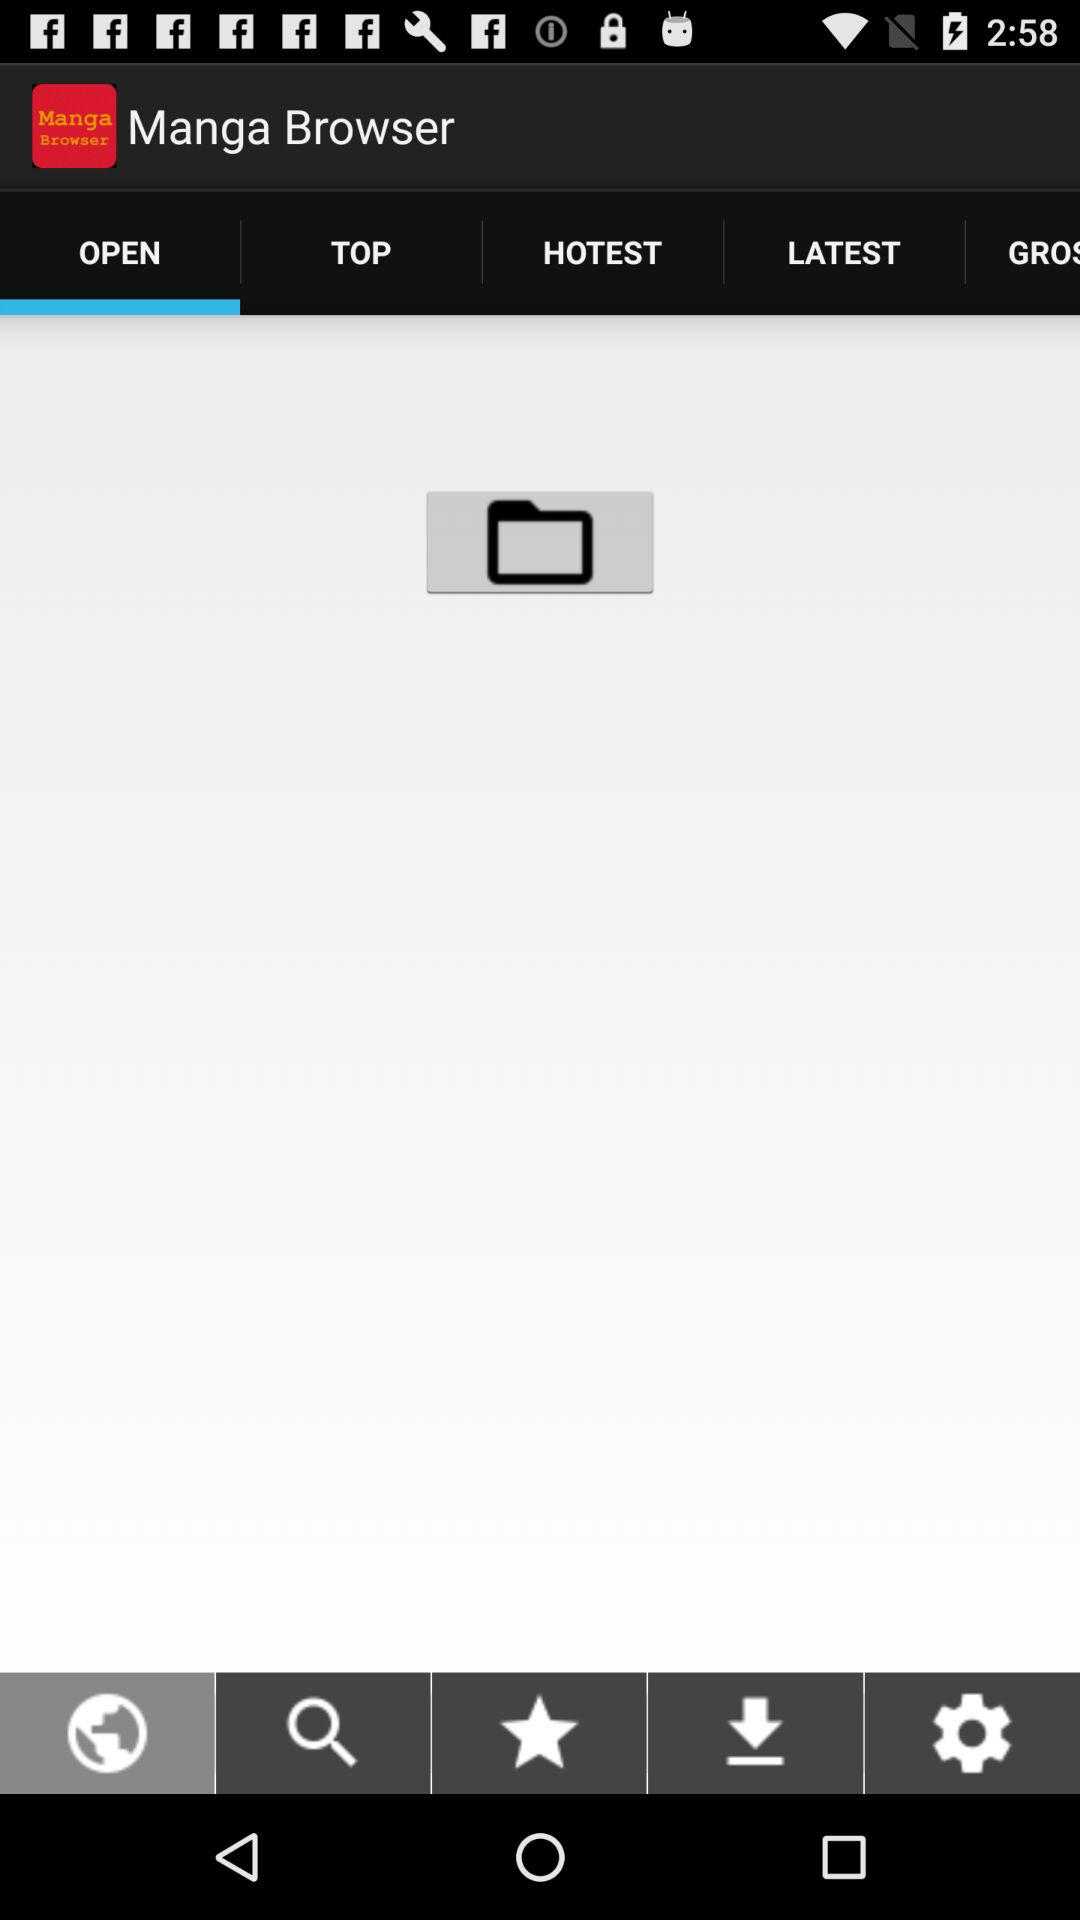Which tab am I on? You are on the "OPEN" tab. 